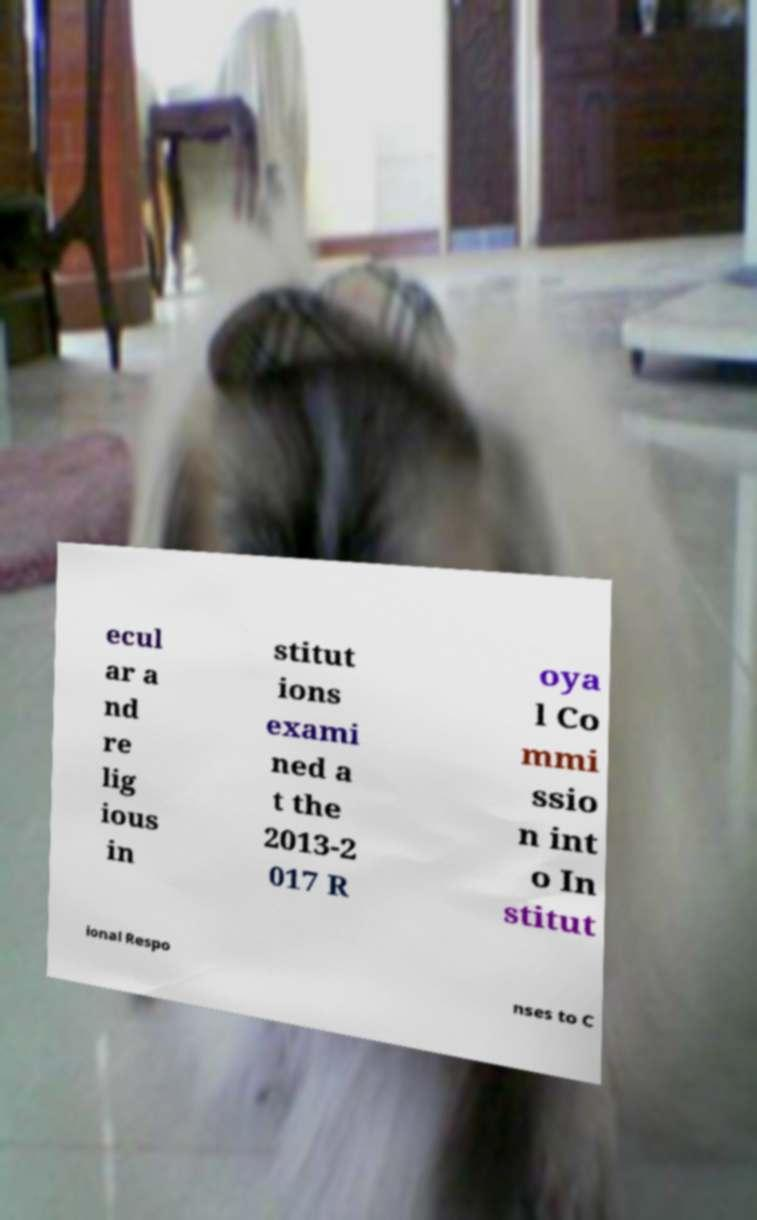For documentation purposes, I need the text within this image transcribed. Could you provide that? ecul ar a nd re lig ious in stitut ions exami ned a t the 2013-2 017 R oya l Co mmi ssio n int o In stitut ional Respo nses to C 